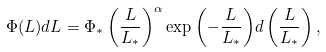Convert formula to latex. <formula><loc_0><loc_0><loc_500><loc_500>\Phi ( L ) d L = \Phi _ { * } \left ( \frac { L } { L _ { * } } \right ) ^ { \alpha } \exp { \left ( - \frac { L } { L _ { * } } \right ) } d \left ( \frac { L } { L _ { * } } \right ) ,</formula> 